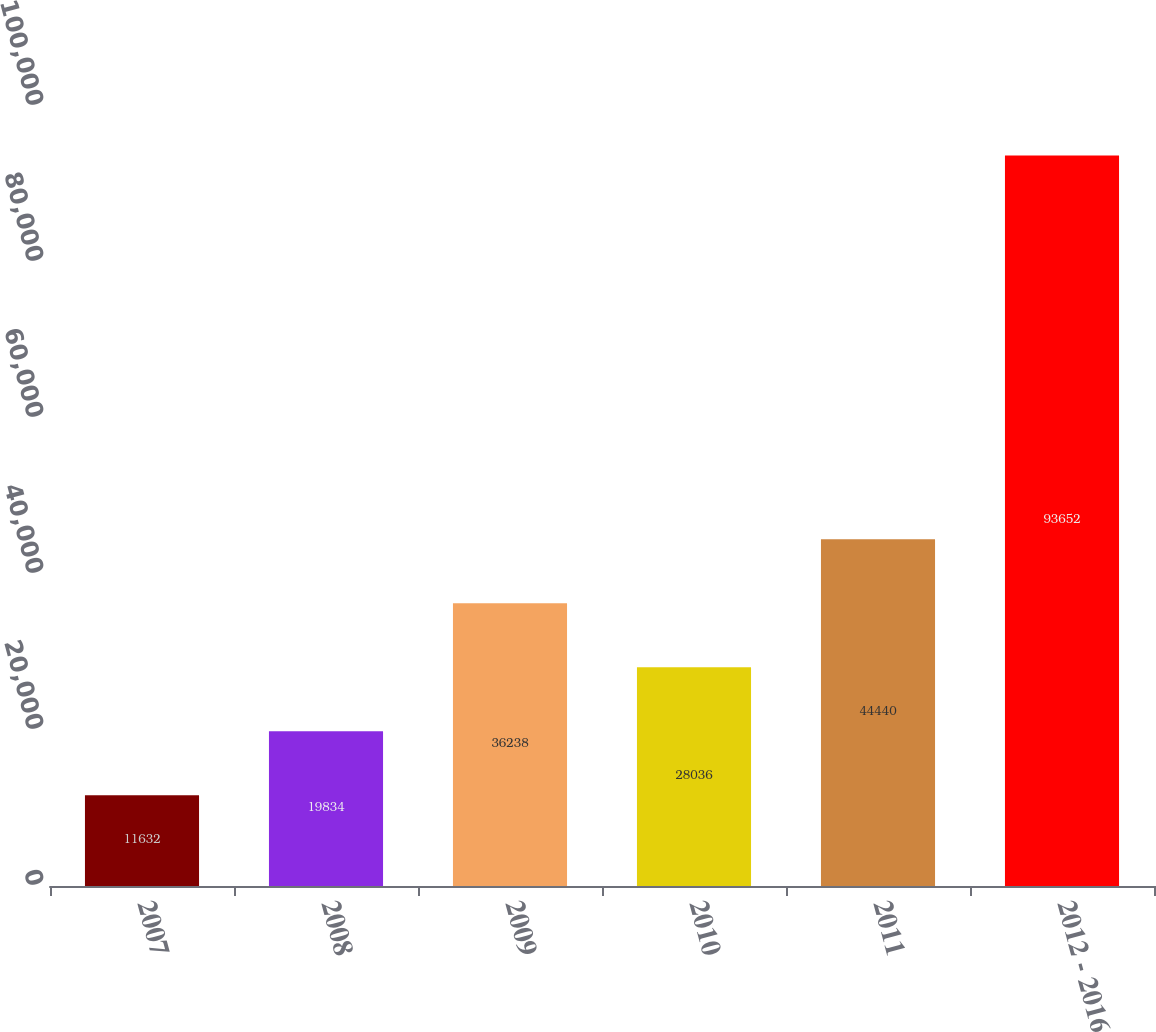<chart> <loc_0><loc_0><loc_500><loc_500><bar_chart><fcel>2007<fcel>2008<fcel>2009<fcel>2010<fcel>2011<fcel>2012 - 2016<nl><fcel>11632<fcel>19834<fcel>36238<fcel>28036<fcel>44440<fcel>93652<nl></chart> 